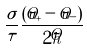<formula> <loc_0><loc_0><loc_500><loc_500>\frac { \sigma } { \tau } \frac { ( \hat { u } _ { + } - \hat { u } _ { - } ) } { 2 \hat { h } }</formula> 